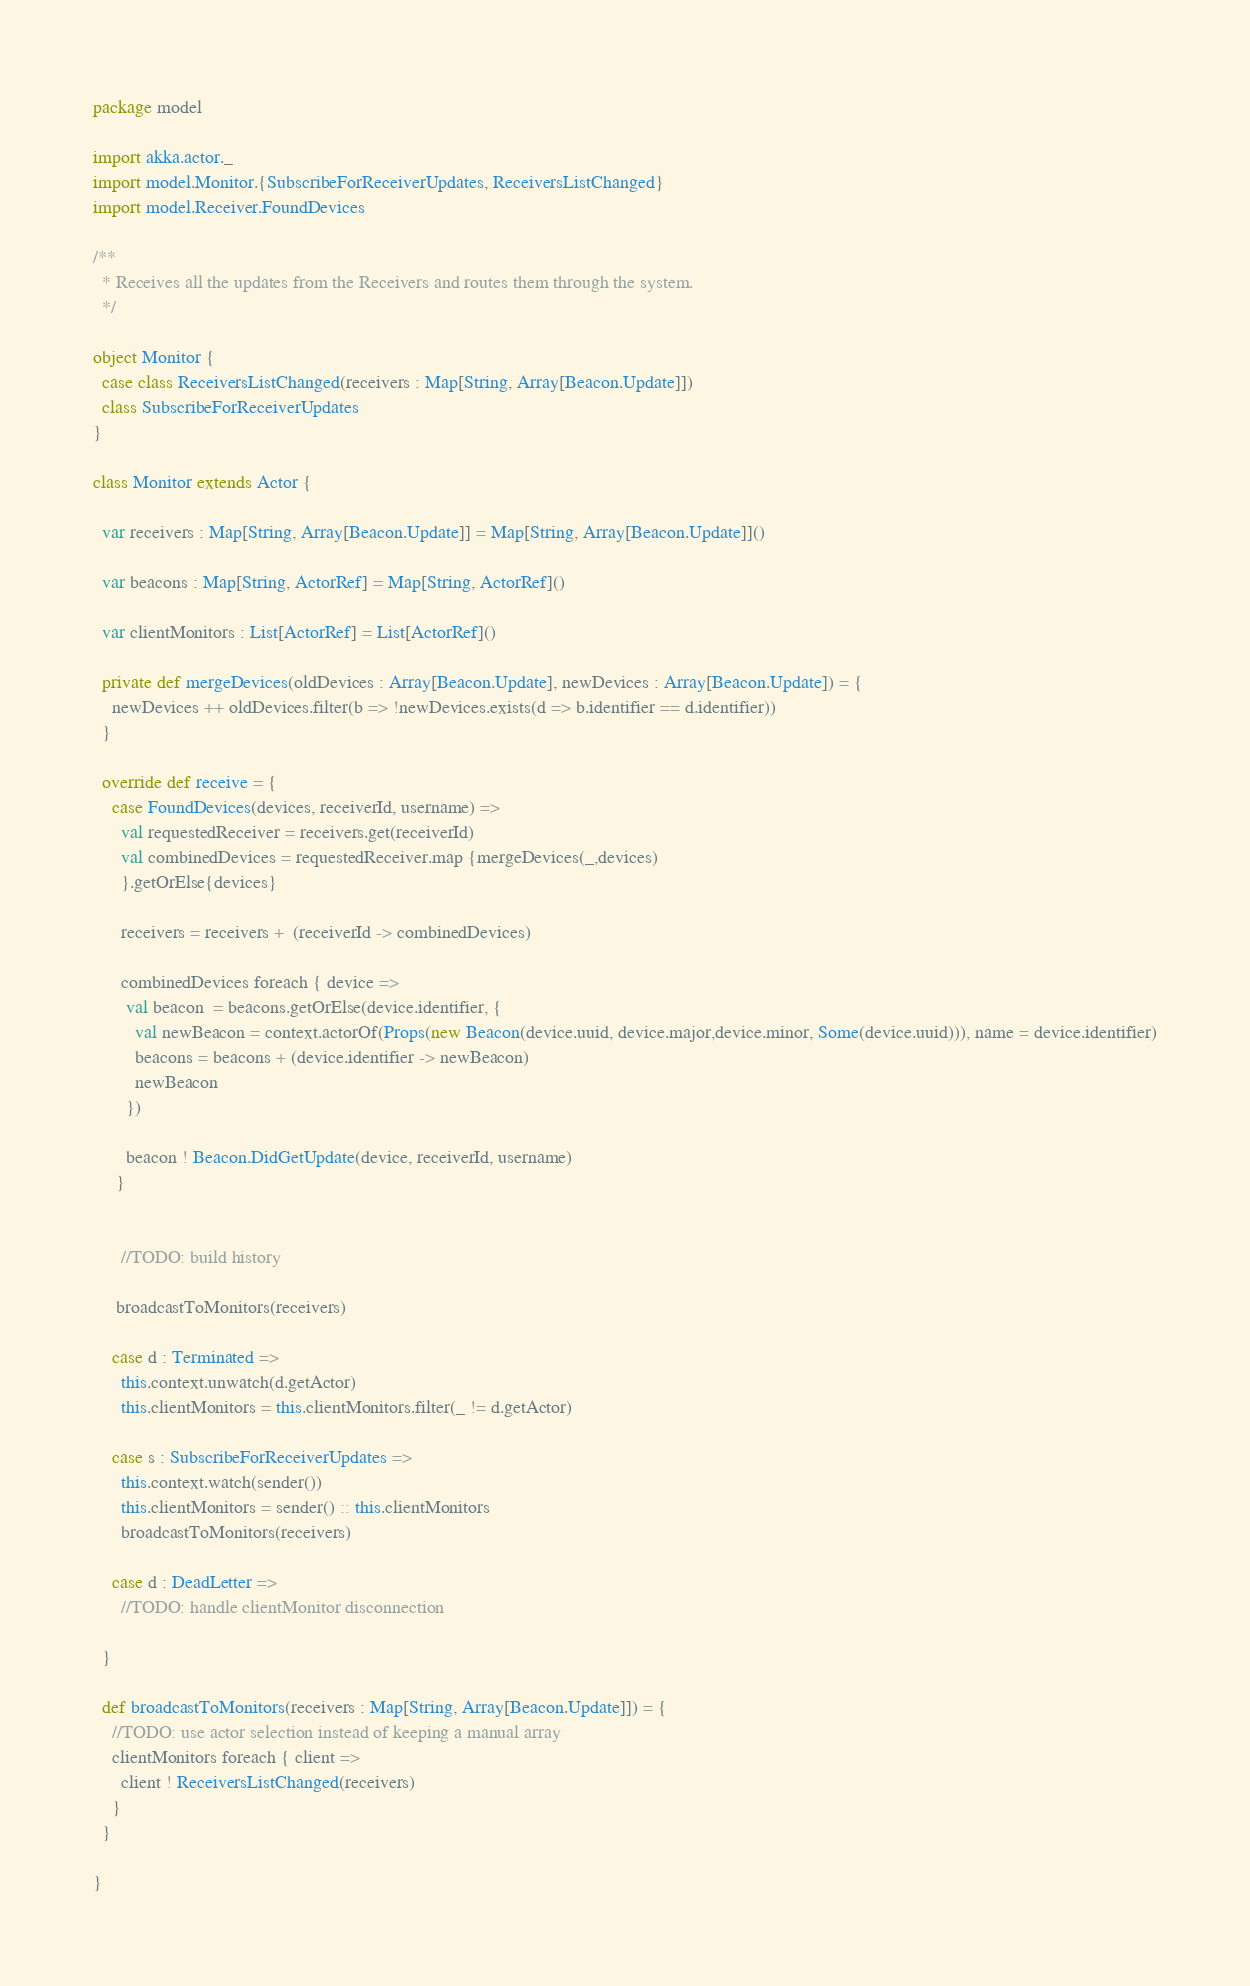Convert code to text. <code><loc_0><loc_0><loc_500><loc_500><_Scala_>package model

import akka.actor._
import model.Monitor.{SubscribeForReceiverUpdates, ReceiversListChanged}
import model.Receiver.FoundDevices

/**
  * Receives all the updates from the Receivers and routes them through the system.
  */

object Monitor {
  case class ReceiversListChanged(receivers : Map[String, Array[Beacon.Update]])
  class SubscribeForReceiverUpdates
}

class Monitor extends Actor {

  var receivers : Map[String, Array[Beacon.Update]] = Map[String, Array[Beacon.Update]]()

  var beacons : Map[String, ActorRef] = Map[String, ActorRef]()

  var clientMonitors : List[ActorRef] = List[ActorRef]()

  private def mergeDevices(oldDevices : Array[Beacon.Update], newDevices : Array[Beacon.Update]) = {
    newDevices ++ oldDevices.filter(b => !newDevices.exists(d => b.identifier == d.identifier))
  }

  override def receive = {
    case FoundDevices(devices, receiverId, username) =>
      val requestedReceiver = receivers.get(receiverId)
      val combinedDevices = requestedReceiver.map {mergeDevices(_,devices)
      }.getOrElse{devices}

      receivers = receivers +  (receiverId -> combinedDevices)

      combinedDevices foreach { device =>
       val beacon  = beacons.getOrElse(device.identifier, {
         val newBeacon = context.actorOf(Props(new Beacon(device.uuid, device.major,device.minor, Some(device.uuid))), name = device.identifier)
         beacons = beacons + (device.identifier -> newBeacon)
         newBeacon
       })

       beacon ! Beacon.DidGetUpdate(device, receiverId, username)
     }


      //TODO: build history

     broadcastToMonitors(receivers)

    case d : Terminated =>
      this.context.unwatch(d.getActor)
      this.clientMonitors = this.clientMonitors.filter(_ != d.getActor)

    case s : SubscribeForReceiverUpdates =>
      this.context.watch(sender())
      this.clientMonitors = sender() :: this.clientMonitors
      broadcastToMonitors(receivers)

    case d : DeadLetter =>
      //TODO: handle clientMonitor disconnection

  }

  def broadcastToMonitors(receivers : Map[String, Array[Beacon.Update]]) = {
    //TODO: use actor selection instead of keeping a manual array
    clientMonitors foreach { client =>
      client ! ReceiversListChanged(receivers)
    }
  }

}
</code> 